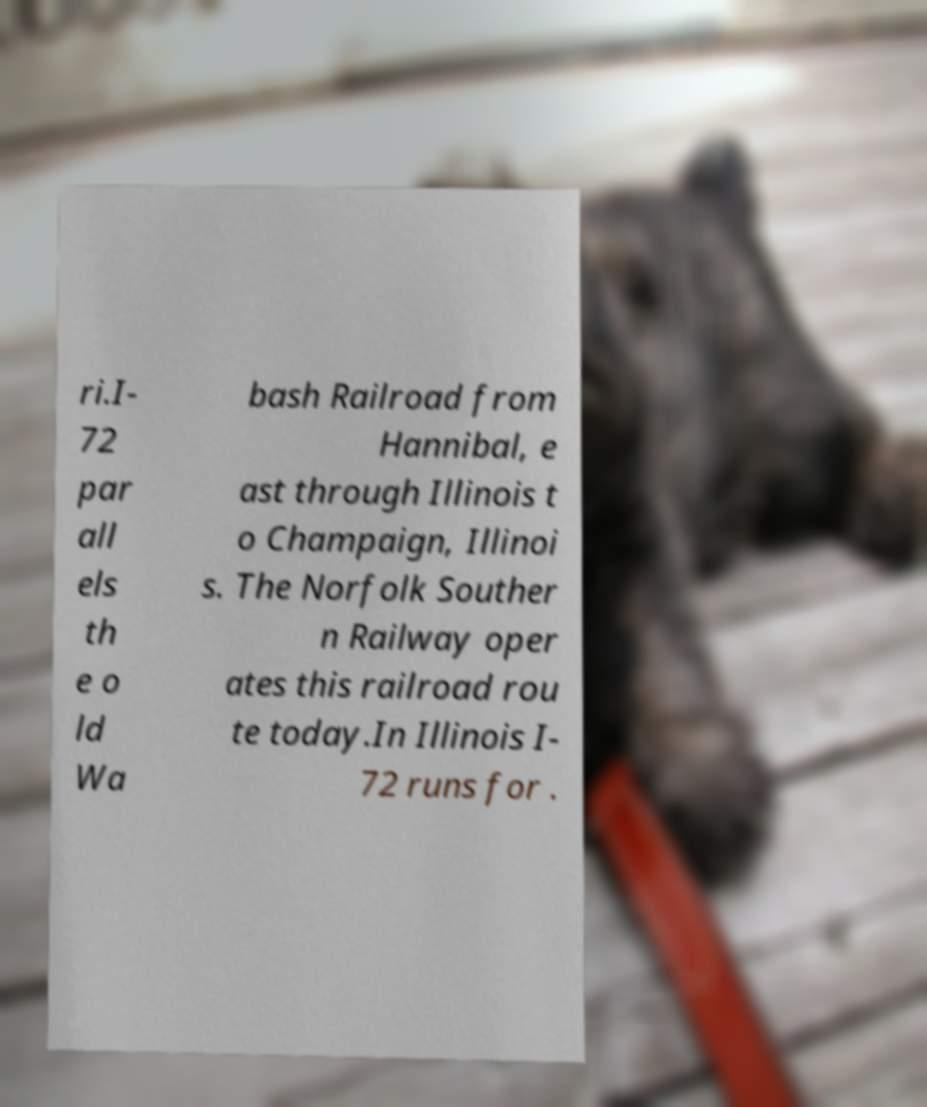Can you accurately transcribe the text from the provided image for me? ri.I- 72 par all els th e o ld Wa bash Railroad from Hannibal, e ast through Illinois t o Champaign, Illinoi s. The Norfolk Souther n Railway oper ates this railroad rou te today.In Illinois I- 72 runs for . 